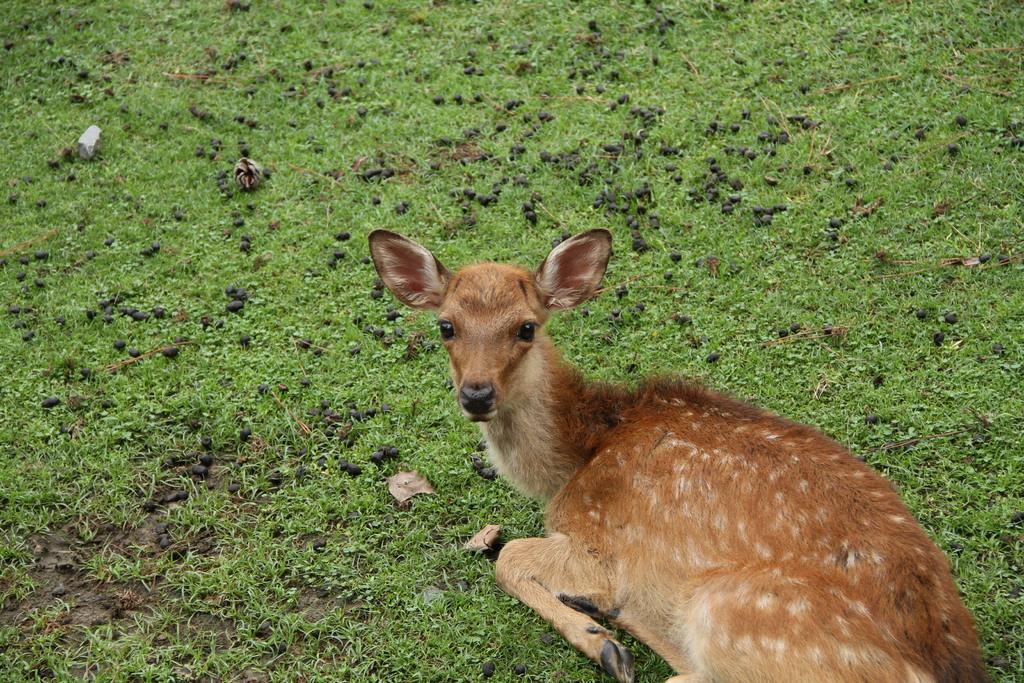What type of animal is in the image? The specific type of animal is not mentioned, but it is an animal that is sitting on the grass. Can you describe the animal's location in the image? The animal is sitting on the grass in the image. What type of planes can be seen flying over the animal in the image? There is no mention of planes in the image, and the animal is sitting on the grass, not under any planes. 